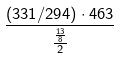Convert formula to latex. <formula><loc_0><loc_0><loc_500><loc_500>\frac { ( 3 3 1 / 2 9 4 ) \cdot 4 6 3 } { \frac { \frac { 1 3 } { 8 } } { 2 } }</formula> 